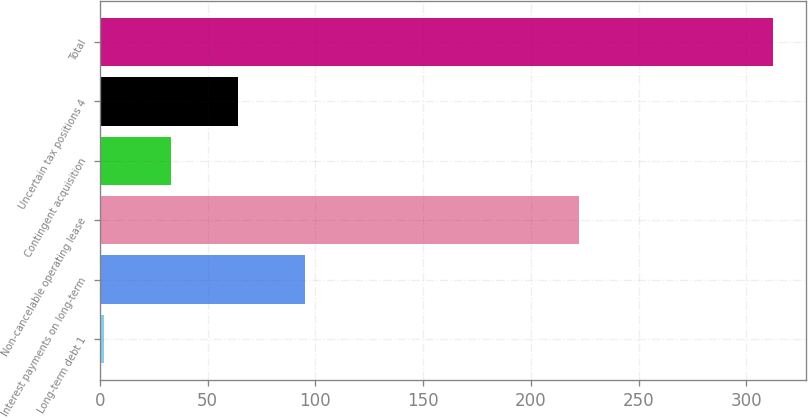Convert chart. <chart><loc_0><loc_0><loc_500><loc_500><bar_chart><fcel>Long-term debt 1<fcel>Interest payments on long-term<fcel>Non-cancelable operating lease<fcel>Contingent acquisition<fcel>Uncertain tax positions 4<fcel>Total<nl><fcel>2<fcel>95.06<fcel>222.2<fcel>33.02<fcel>64.04<fcel>312.2<nl></chart> 